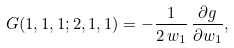<formula> <loc_0><loc_0><loc_500><loc_500>G ( 1 , 1 , 1 ; 2 , 1 , 1 ) = - \frac { 1 } { 2 \, w _ { 1 } } \, \frac { \partial g } { \partial w _ { 1 } } ,</formula> 